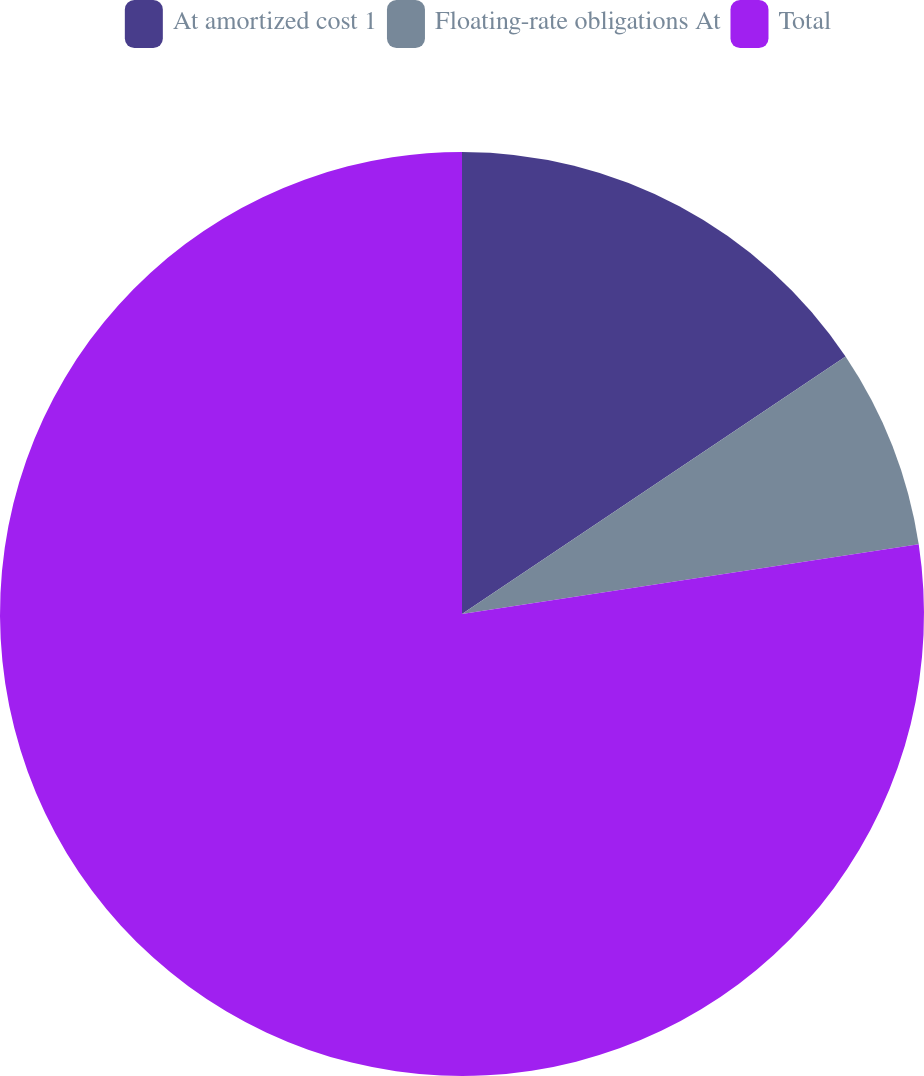<chart> <loc_0><loc_0><loc_500><loc_500><pie_chart><fcel>At amortized cost 1<fcel>Floating-rate obligations At<fcel>Total<nl><fcel>15.59%<fcel>7.0%<fcel>77.41%<nl></chart> 